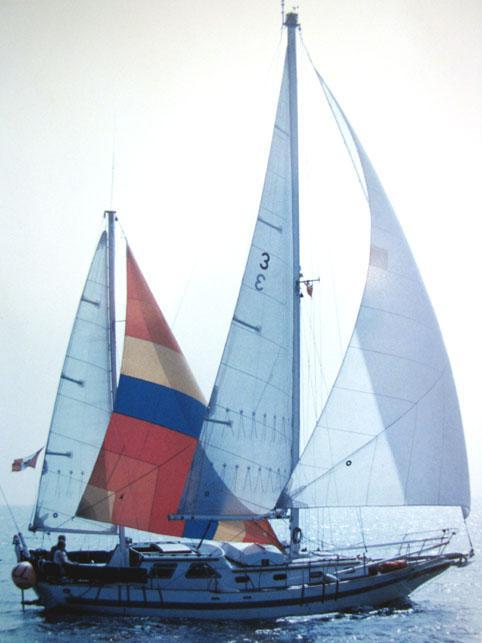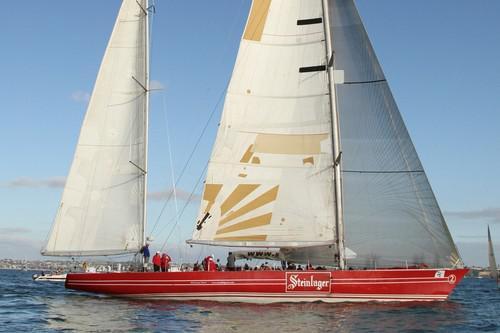The first image is the image on the left, the second image is the image on the right. For the images displayed, is the sentence "The sailboat in the right image is tipped rightward, showing its interior." factually correct? Answer yes or no. No. The first image is the image on the left, the second image is the image on the right. For the images displayed, is the sentence "One boat only has two sails unfurled." factually correct? Answer yes or no. No. 